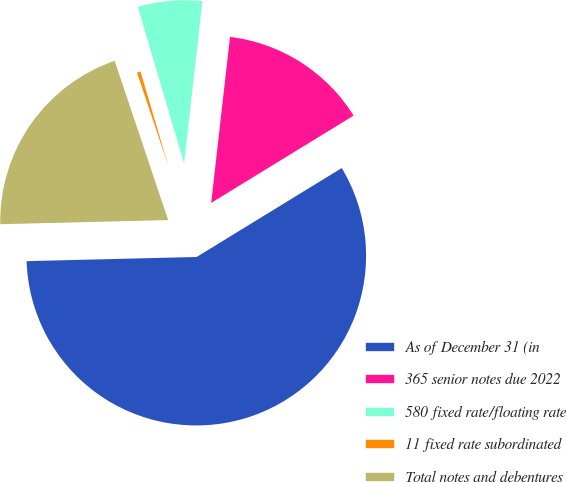Convert chart. <chart><loc_0><loc_0><loc_500><loc_500><pie_chart><fcel>As of December 31 (in<fcel>365 senior notes due 2022<fcel>580 fixed rate/floating rate<fcel>11 fixed rate subordinated<fcel>Total notes and debentures<nl><fcel>58.36%<fcel>14.45%<fcel>6.37%<fcel>0.59%<fcel>20.23%<nl></chart> 